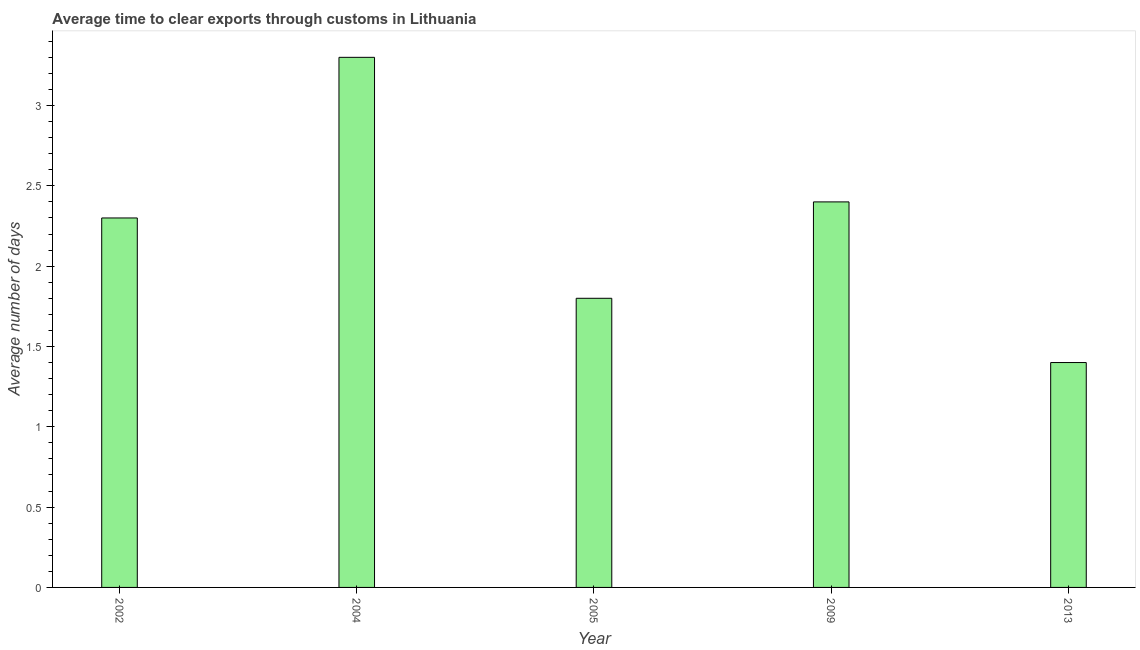Does the graph contain grids?
Provide a succinct answer. No. What is the title of the graph?
Your answer should be compact. Average time to clear exports through customs in Lithuania. What is the label or title of the X-axis?
Offer a terse response. Year. What is the label or title of the Y-axis?
Keep it short and to the point. Average number of days. What is the time to clear exports through customs in 2013?
Offer a very short reply. 1.4. Across all years, what is the minimum time to clear exports through customs?
Your answer should be very brief. 1.4. In which year was the time to clear exports through customs minimum?
Keep it short and to the point. 2013. What is the sum of the time to clear exports through customs?
Your response must be concise. 11.2. What is the average time to clear exports through customs per year?
Your response must be concise. 2.24. In how many years, is the time to clear exports through customs greater than 1.5 days?
Keep it short and to the point. 4. What is the ratio of the time to clear exports through customs in 2005 to that in 2013?
Ensure brevity in your answer.  1.29. Is the time to clear exports through customs in 2004 less than that in 2009?
Ensure brevity in your answer.  No. What is the difference between the highest and the second highest time to clear exports through customs?
Offer a very short reply. 0.9. In how many years, is the time to clear exports through customs greater than the average time to clear exports through customs taken over all years?
Offer a very short reply. 3. How many bars are there?
Offer a very short reply. 5. How many years are there in the graph?
Give a very brief answer. 5. What is the Average number of days in 2004?
Give a very brief answer. 3.3. What is the difference between the Average number of days in 2002 and 2009?
Your response must be concise. -0.1. What is the difference between the Average number of days in 2002 and 2013?
Provide a succinct answer. 0.9. What is the difference between the Average number of days in 2004 and 2005?
Provide a succinct answer. 1.5. What is the difference between the Average number of days in 2004 and 2009?
Your response must be concise. 0.9. What is the difference between the Average number of days in 2009 and 2013?
Make the answer very short. 1. What is the ratio of the Average number of days in 2002 to that in 2004?
Your answer should be very brief. 0.7. What is the ratio of the Average number of days in 2002 to that in 2005?
Keep it short and to the point. 1.28. What is the ratio of the Average number of days in 2002 to that in 2009?
Offer a very short reply. 0.96. What is the ratio of the Average number of days in 2002 to that in 2013?
Offer a terse response. 1.64. What is the ratio of the Average number of days in 2004 to that in 2005?
Offer a very short reply. 1.83. What is the ratio of the Average number of days in 2004 to that in 2009?
Give a very brief answer. 1.38. What is the ratio of the Average number of days in 2004 to that in 2013?
Offer a terse response. 2.36. What is the ratio of the Average number of days in 2005 to that in 2013?
Make the answer very short. 1.29. What is the ratio of the Average number of days in 2009 to that in 2013?
Provide a succinct answer. 1.71. 